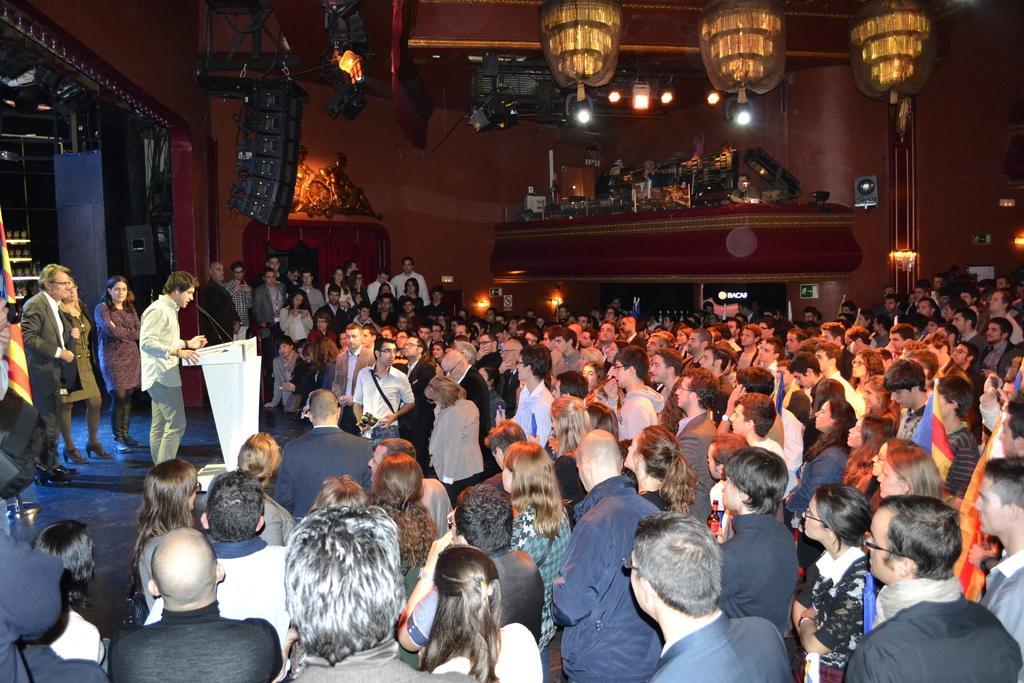Can you describe this image briefly? In this image I can see so many people are standing among them one person is standing and talking in front of the mike, around I can see some objects are placed in the hall. 